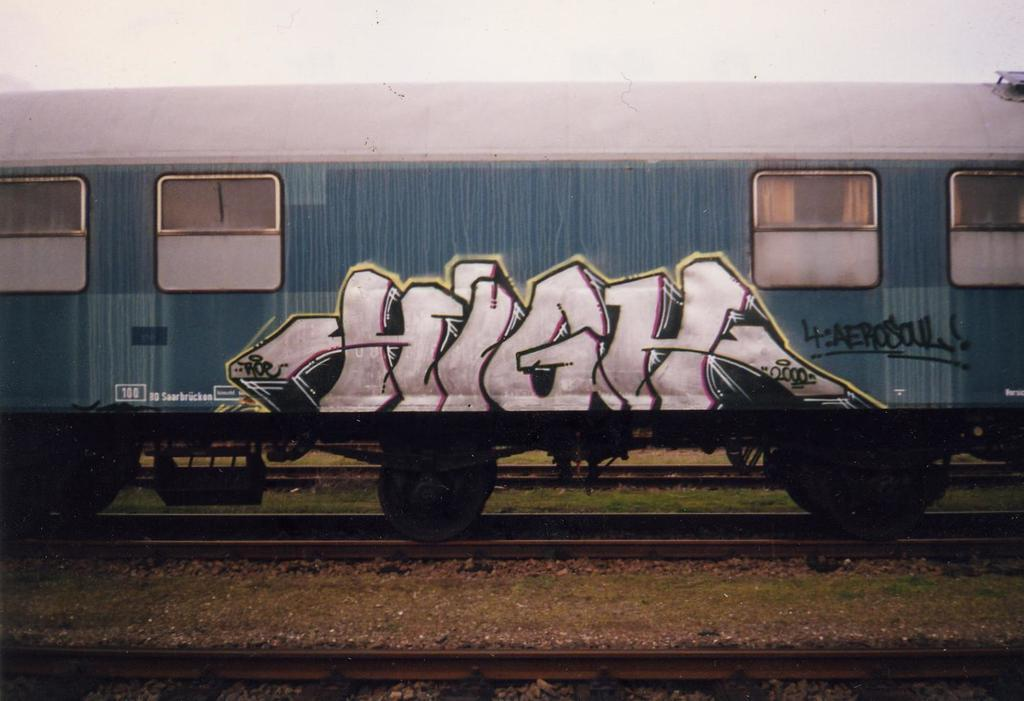<image>
Offer a succinct explanation of the picture presented. the word high in graffiti on the side of a train 